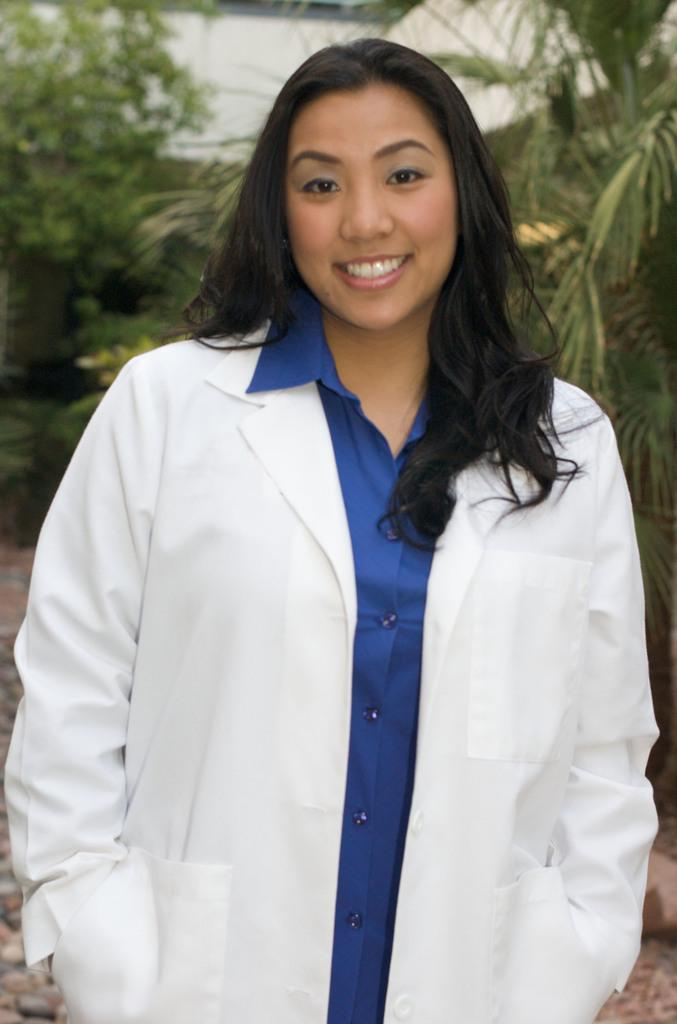Who is the main subject in the image? There is a woman in the image. What is the woman wearing? The woman is wearing a white coat. What expression does the woman have? The woman is smiling. Can you describe the background of the image? The background of the image is blurry. What type of vegetation can be seen in the background? There are plants visible in the background. What type of cart is being pulled by the goldfish in the image? There is no cart or goldfish present in the image. What songs can be heard playing in the background of the image? There is no audio or music present in the image. 